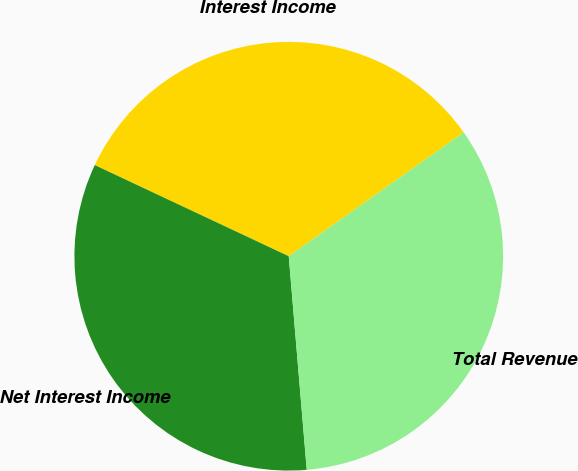Convert chart to OTSL. <chart><loc_0><loc_0><loc_500><loc_500><pie_chart><fcel>Interest Income<fcel>Net Interest Income<fcel>Total Revenue<nl><fcel>33.2%<fcel>33.33%<fcel>33.47%<nl></chart> 